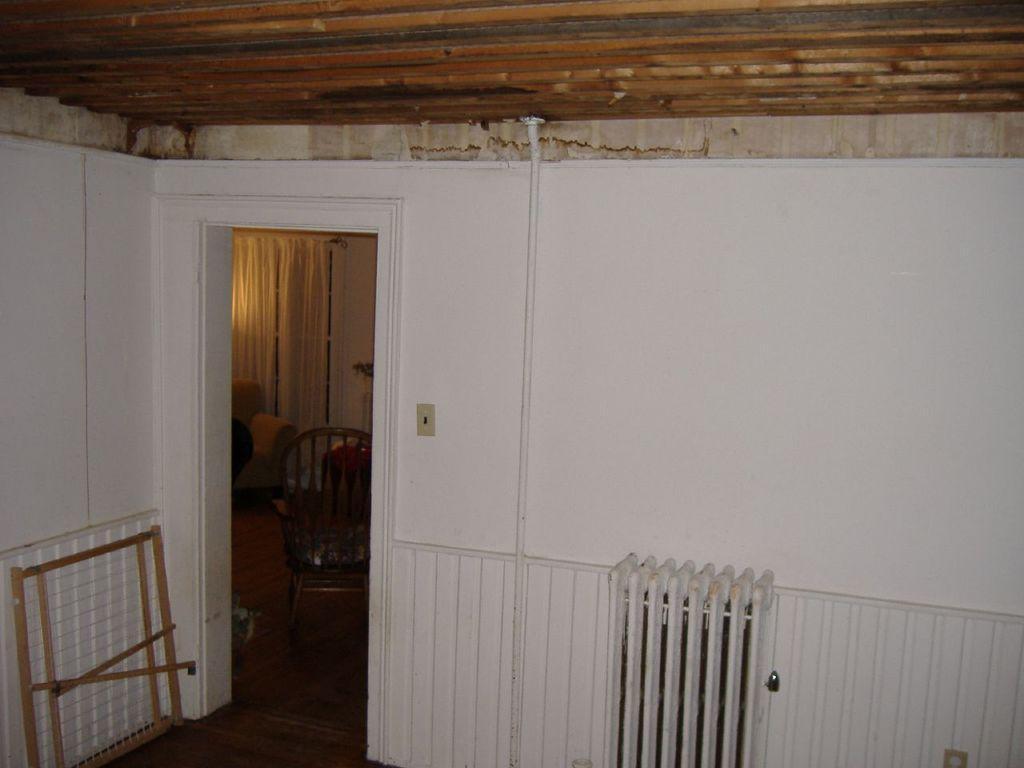In one or two sentences, can you explain what this image depicts? In this picture there is an object which is in white color and there is a wooden object in the left corner and there is a wooden roof above it and there is a chair,sofa and curtains in the background. 